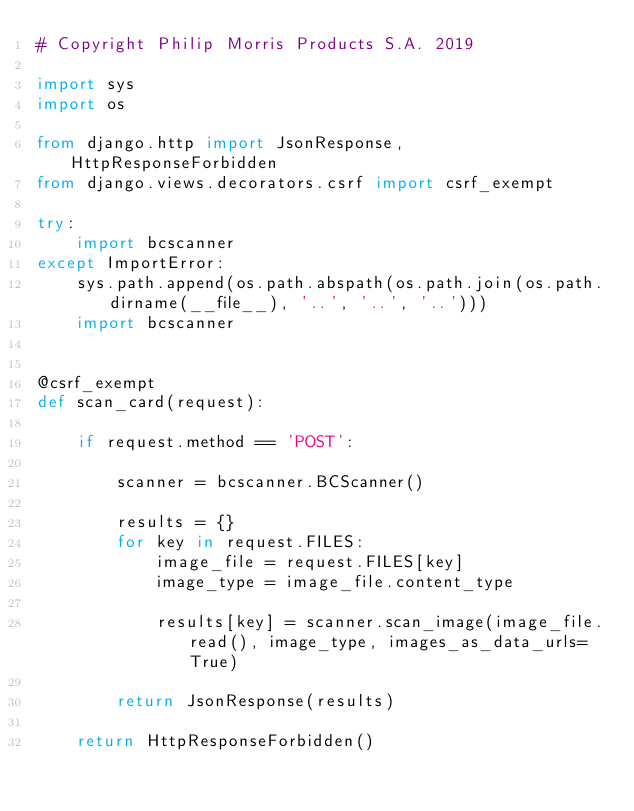<code> <loc_0><loc_0><loc_500><loc_500><_Python_># Copyright Philip Morris Products S.A. 2019

import sys
import os

from django.http import JsonResponse, HttpResponseForbidden
from django.views.decorators.csrf import csrf_exempt

try:
    import bcscanner
except ImportError:
    sys.path.append(os.path.abspath(os.path.join(os.path.dirname(__file__), '..', '..', '..')))
    import bcscanner


@csrf_exempt
def scan_card(request):

    if request.method == 'POST':

        scanner = bcscanner.BCScanner()

        results = {}
        for key in request.FILES:
            image_file = request.FILES[key]
            image_type = image_file.content_type

            results[key] = scanner.scan_image(image_file.read(), image_type, images_as_data_urls=True)

        return JsonResponse(results)

    return HttpResponseForbidden()
</code> 